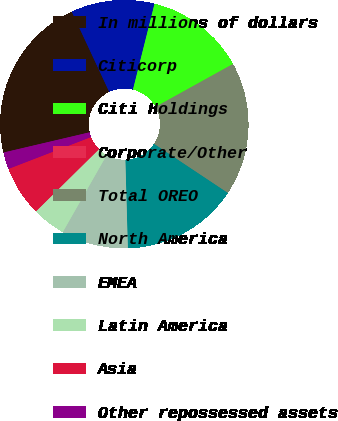<chart> <loc_0><loc_0><loc_500><loc_500><pie_chart><fcel>In millions of dollars<fcel>Citicorp<fcel>Citi Holdings<fcel>Corporate/Other<fcel>Total OREO<fcel>North America<fcel>EMEA<fcel>Latin America<fcel>Asia<fcel>Other repossessed assets<nl><fcel>21.72%<fcel>10.87%<fcel>13.04%<fcel>0.01%<fcel>17.38%<fcel>15.21%<fcel>8.7%<fcel>4.36%<fcel>6.53%<fcel>2.19%<nl></chart> 